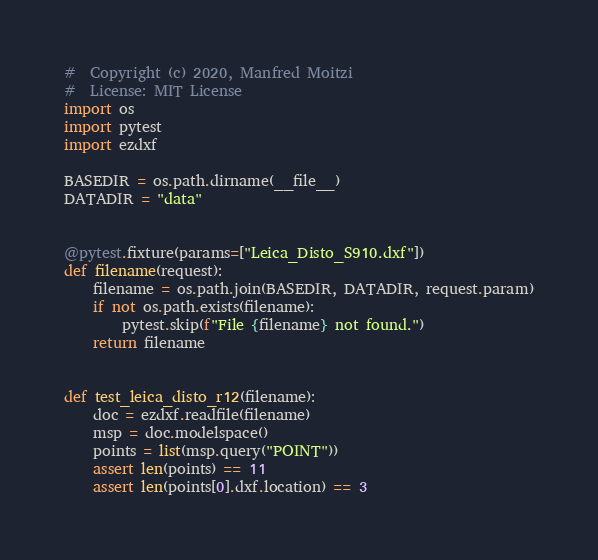<code> <loc_0><loc_0><loc_500><loc_500><_Python_>#  Copyright (c) 2020, Manfred Moitzi
#  License: MIT License
import os
import pytest
import ezdxf

BASEDIR = os.path.dirname(__file__)
DATADIR = "data"


@pytest.fixture(params=["Leica_Disto_S910.dxf"])
def filename(request):
    filename = os.path.join(BASEDIR, DATADIR, request.param)
    if not os.path.exists(filename):
        pytest.skip(f"File {filename} not found.")
    return filename


def test_leica_disto_r12(filename):
    doc = ezdxf.readfile(filename)
    msp = doc.modelspace()
    points = list(msp.query("POINT"))
    assert len(points) == 11
    assert len(points[0].dxf.location) == 3
</code> 